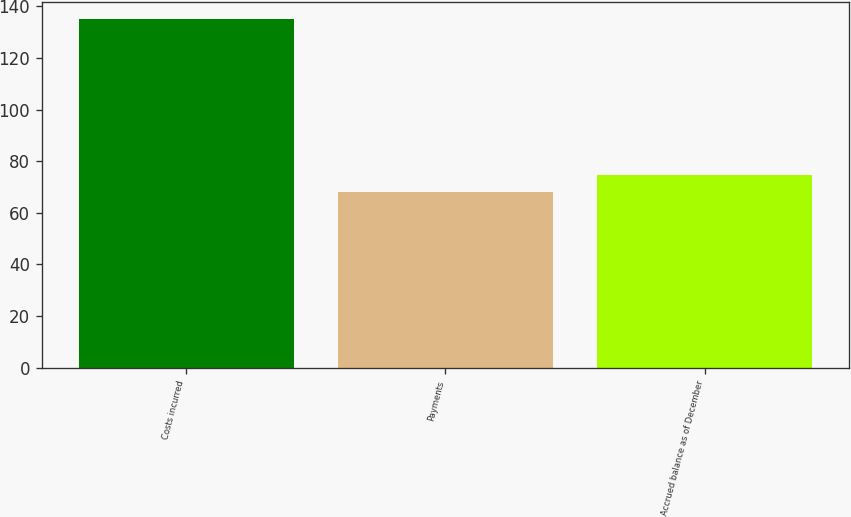<chart> <loc_0><loc_0><loc_500><loc_500><bar_chart><fcel>Costs incurred<fcel>Payments<fcel>Accrued balance as of December<nl><fcel>135<fcel>68<fcel>74.7<nl></chart> 